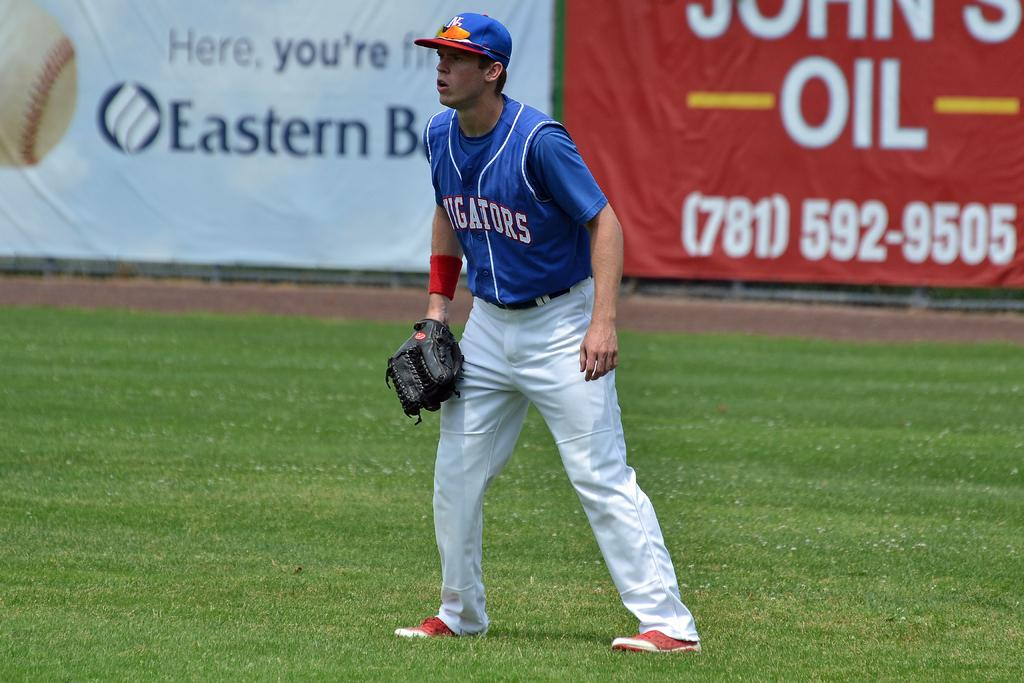<image>
Write a terse but informative summary of the picture. A baseball player wears a Gators jersey and a glove. 